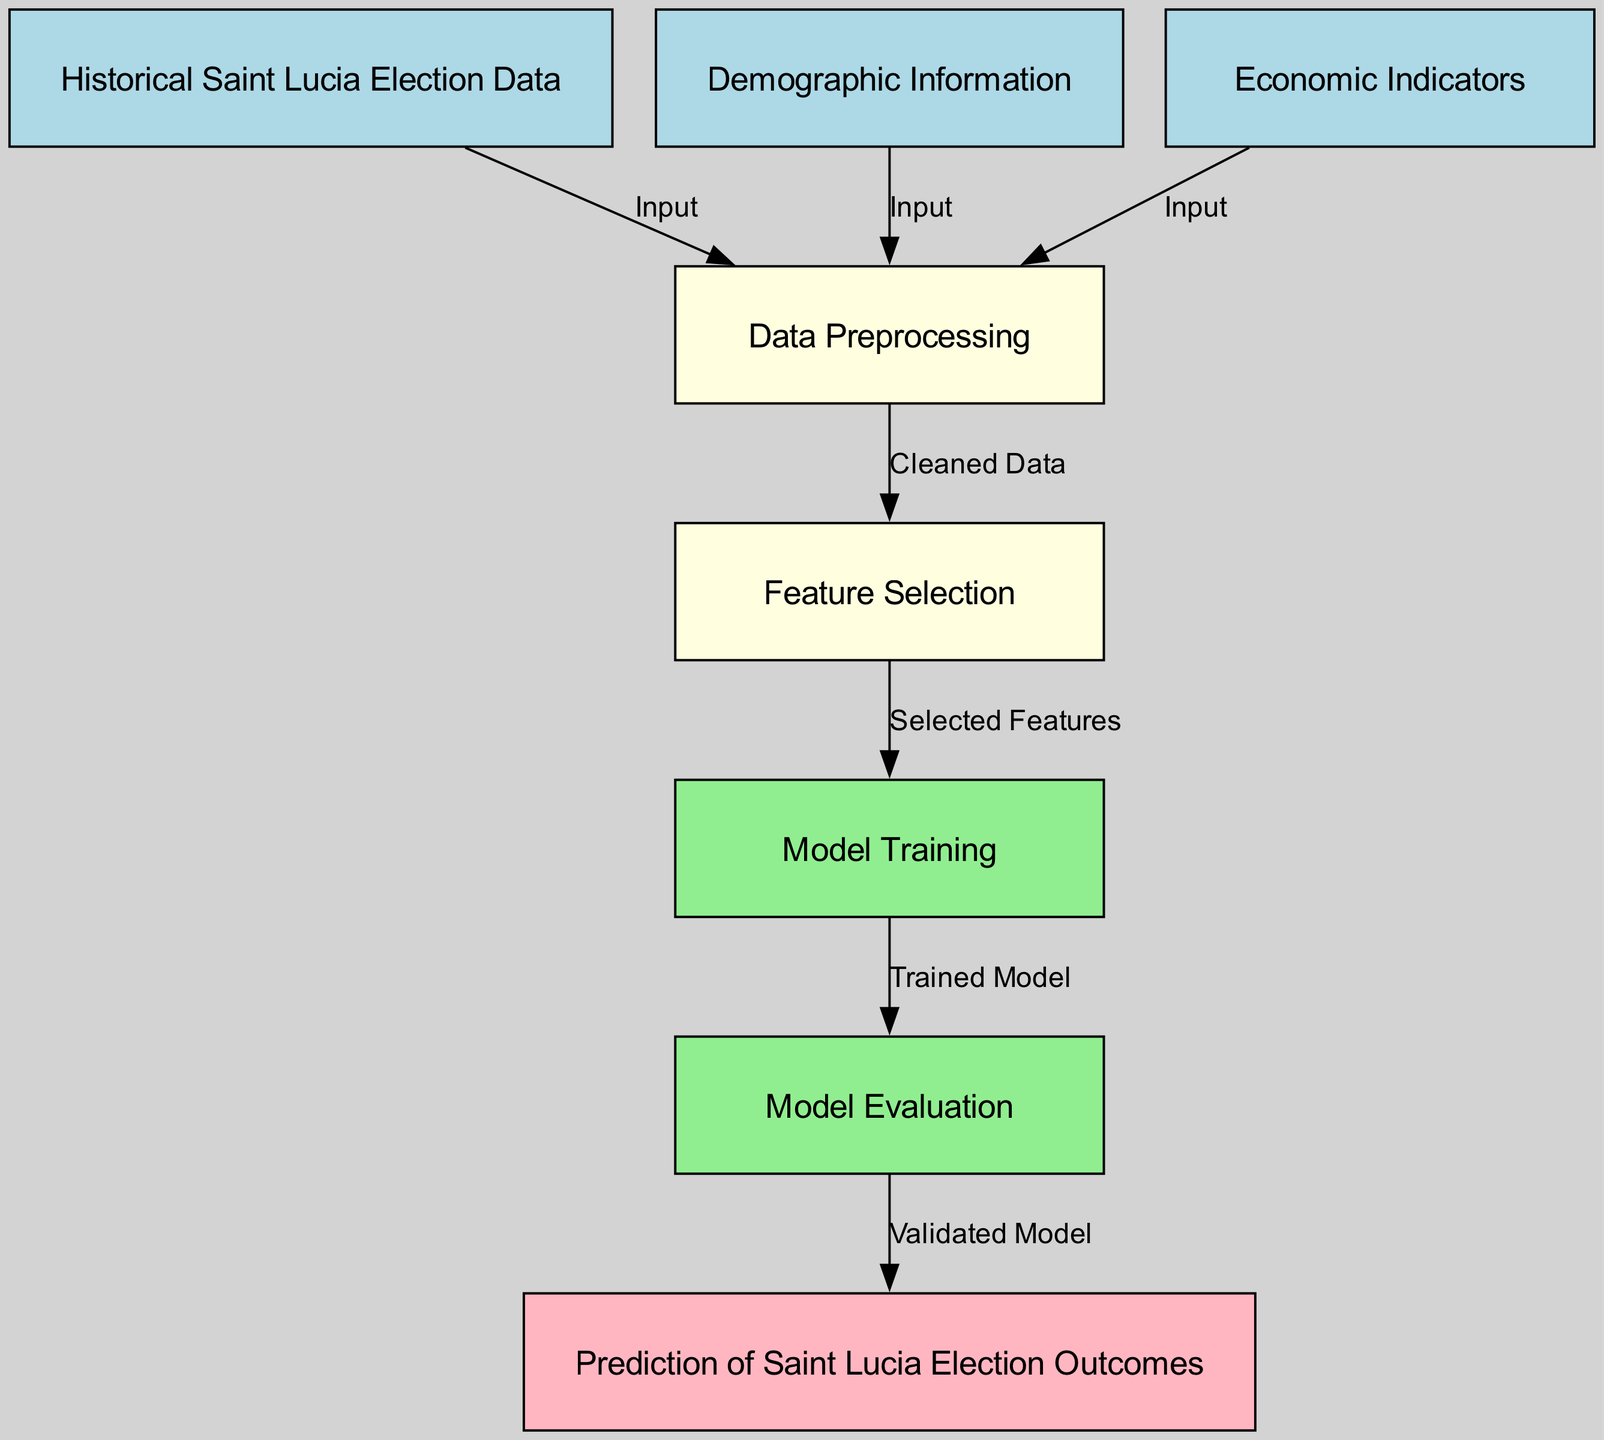What is the first step in the machine learning process depicted in the diagram? The first step, represented by the first node, is "Historical Saint Lucia Election Data." This is the initial input required for the process.
Answer: Historical Saint Lucia Election Data How many nodes are present in the diagram? Counting all the unique nodes in the diagram, there are a total of eight nodes that represent different stages in the machine learning process.
Answer: Eight What connects "Data Preprocessing" to "Feature Selection"? The relationship between "Data Preprocessing" and "Feature Selection" is linked by "Cleaned Data," which indicates that the data must first be preprocessed before features are selected.
Answer: Cleaned Data Which step follows "Model Training" in the diagram? The step that follows "Model Training" in the flowchart is "Model Evaluation," indicating that the trained model is then assessed for its performance.
Answer: Model Evaluation What types of data are input into the machine learning process? The input types consist of "Historical Saint Lucia Election Data," "Demographic Information," and "Economic Indicators," which are all crucial for the analysis.
Answer: Historical Saint Lucia Election Data, Demographic Information, Economic Indicators How many edges are in the diagram? By counting the connections (edges) between the nodes that indicate the flow of the process, there are a total of seven edges present in the diagram.
Answer: Seven What is the final output of the machine learning process illustrated in the diagram? The final output of the process is "Prediction of Saint Lucia Election Outcomes," which is the conclusion of the machine learning workflow.
Answer: Prediction of Saint Lucia Election Outcomes Which step involves selecting important features for the model? The step that involves selecting important features for the model is "Feature Selection," where the most relevant features are identified from the cleaned data.
Answer: Feature Selection What is the color associated with "Model Evaluation" in the diagram? The color associated with "Model Evaluation" is light green, indicating it as part of the model training phase.
Answer: Light green 